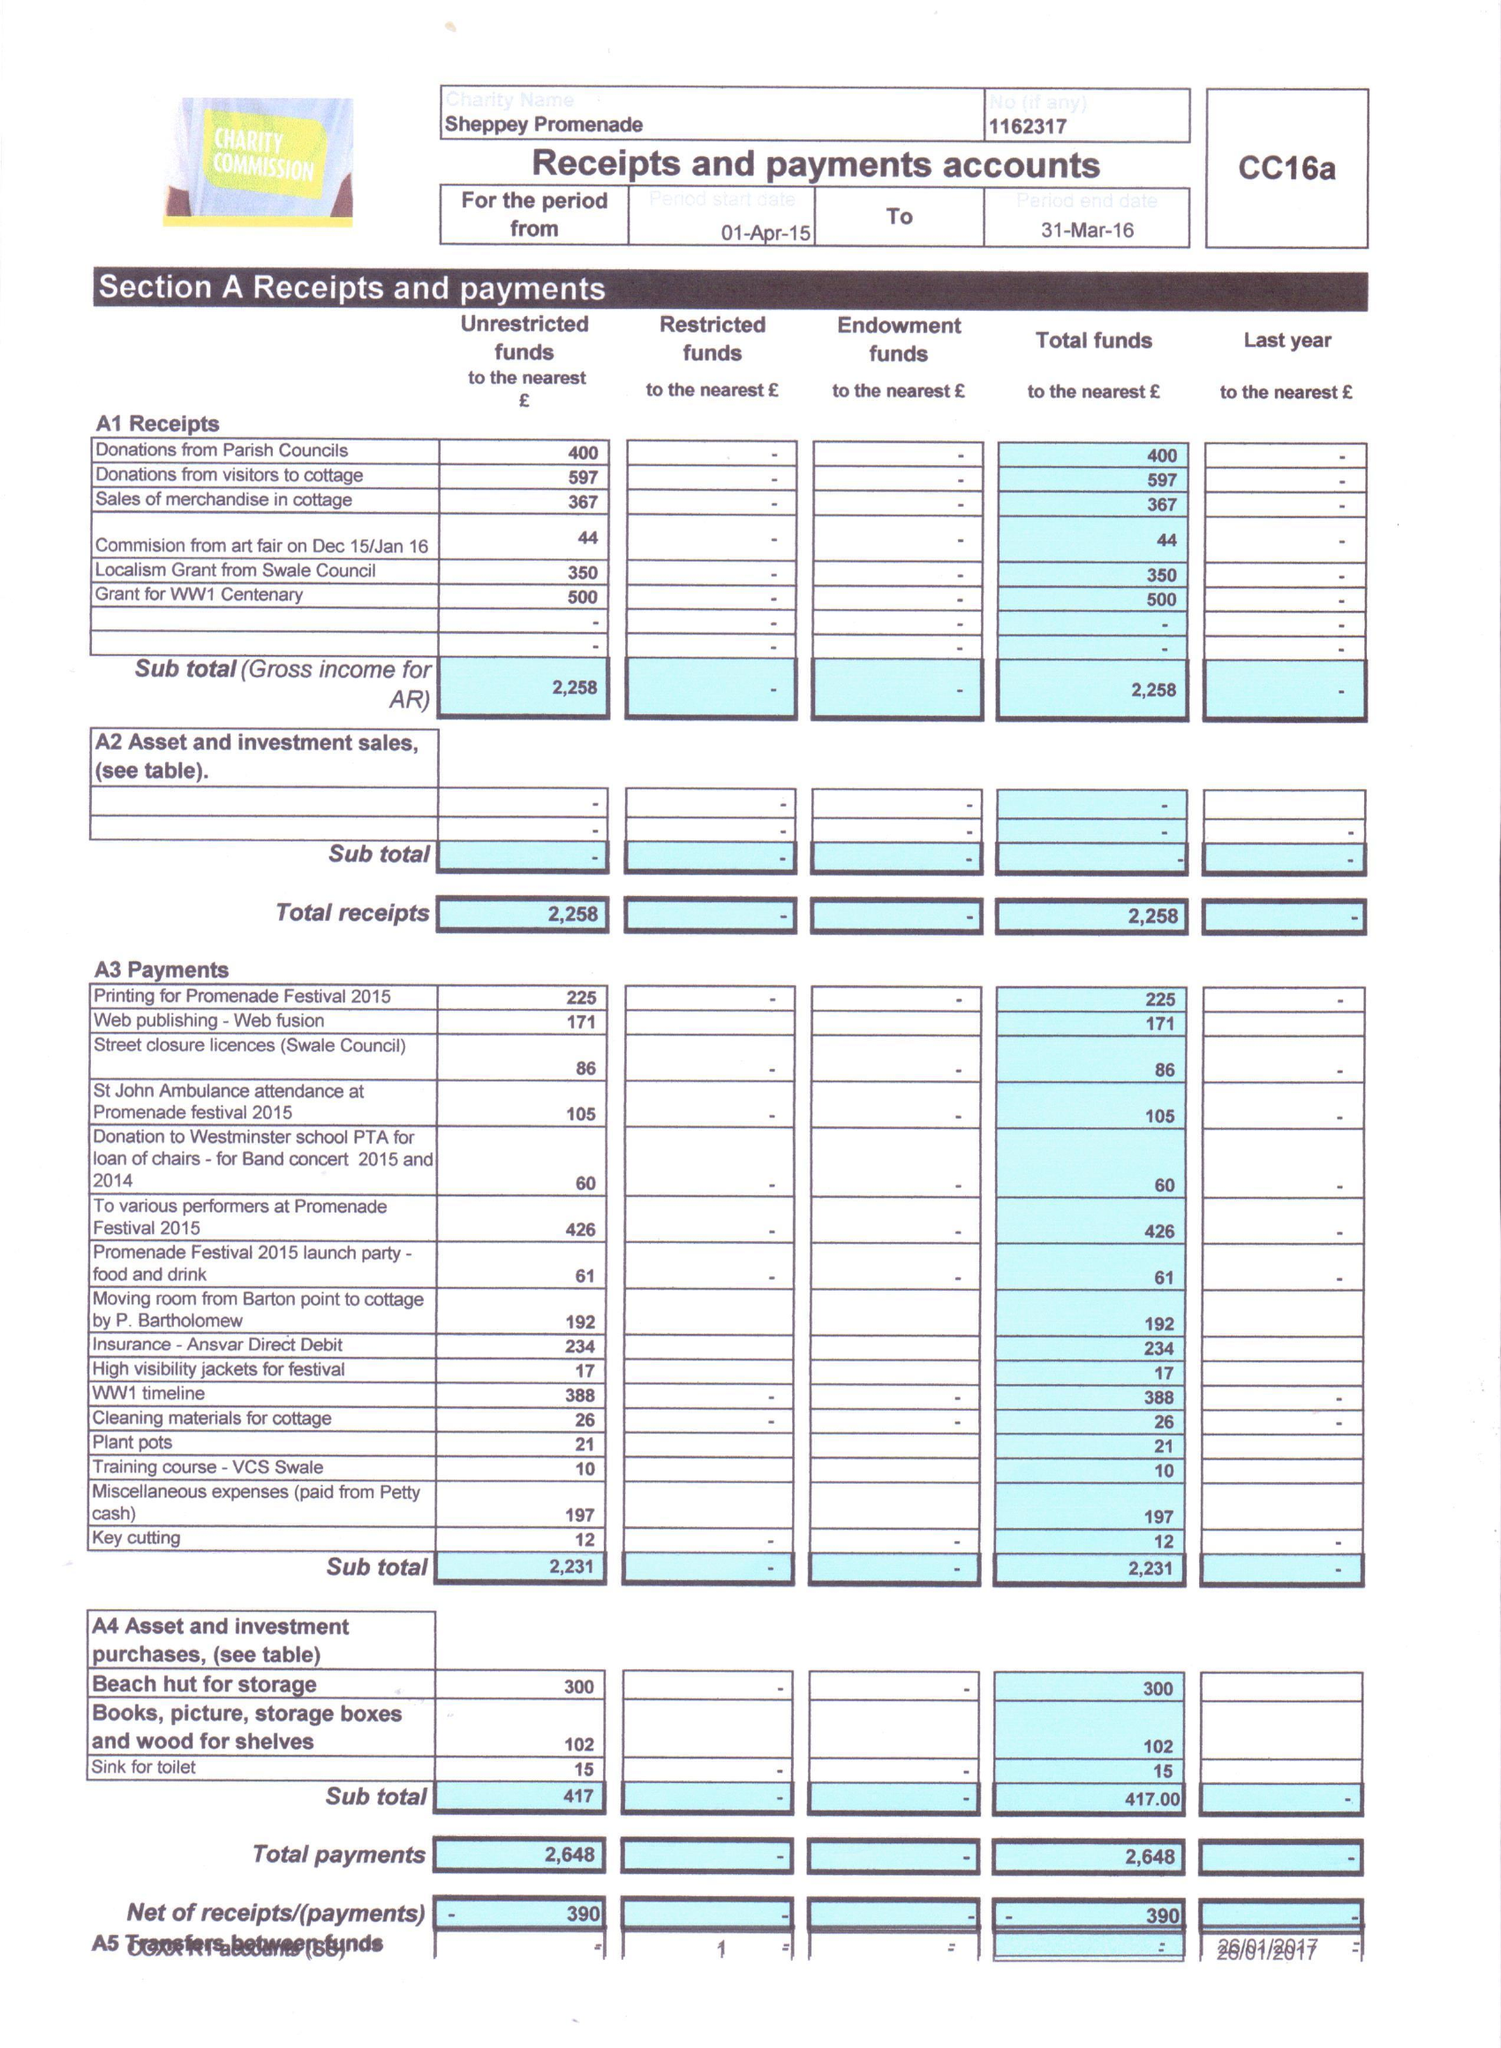What is the value for the income_annually_in_british_pounds?
Answer the question using a single word or phrase. 2258.00 